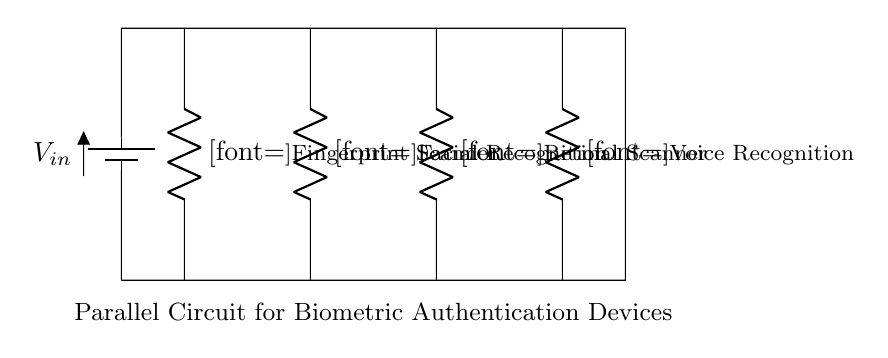What is the total number of biometric devices in the circuit? The circuit diagram shows four distinct resistors, each labeled as a different biometric authentication device. These labels correspond to fingerprint scanner, facial recognition, retinal scanner, and voice recognition, indicating there are four devices.
Answer: Four What is the configuration type of this circuit? The setup shows multiple resistors connected in parallel; each device receives the same voltage from the battery, while the currents can differ, confirming it is a parallel circuit.
Answer: Parallel What is the current path for the fingerprint scanner? The current first passes through the battery, then flows to the fingerprint scanner (R1), indicating the path is from the top node to the bottom node via the resistor for the fingerprint device.
Answer: From battery through R1 What happens to the total resistance when another device is added to the circuit? Adding another resistor in parallel will decrease the total resistance because in parallel circuits, the inverse of total resistance is the sum of the inverses of each individual resistance.
Answer: Decreases What is the voltage across each biometric device? In a parallel circuit configuration, all components share the same voltage, which is equal to the voltage provided by the battery. Therefore, the voltage across each biometric device will be equal to the input voltage.
Answer: Same as Vin Which biometric device has the identifier R3 in the circuit? The label R3 specifically refers to the retinal scanner in the circuit diagram, as it is clearly labeled under that designation in the visual representation.
Answer: Retinal scanner What type of devices does this circuit support? The circuit is designed to support biometric authentication devices such as fingerprint scanners, facial recognition systems, retinal scanners, and voice recognition technologies.
Answer: Biometric authentication devices 